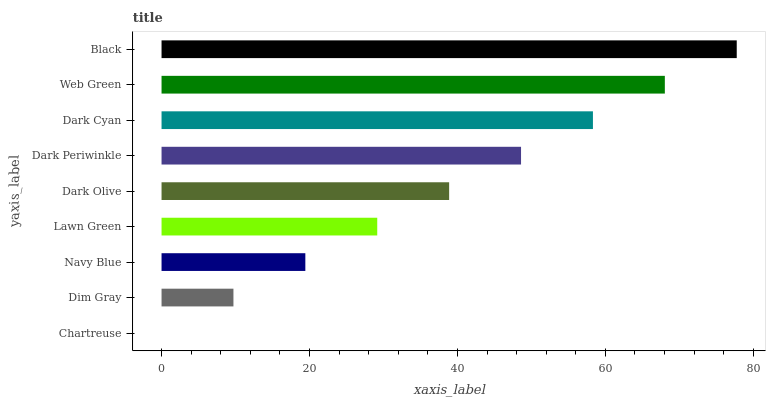Is Chartreuse the minimum?
Answer yes or no. Yes. Is Black the maximum?
Answer yes or no. Yes. Is Dim Gray the minimum?
Answer yes or no. No. Is Dim Gray the maximum?
Answer yes or no. No. Is Dim Gray greater than Chartreuse?
Answer yes or no. Yes. Is Chartreuse less than Dim Gray?
Answer yes or no. Yes. Is Chartreuse greater than Dim Gray?
Answer yes or no. No. Is Dim Gray less than Chartreuse?
Answer yes or no. No. Is Dark Olive the high median?
Answer yes or no. Yes. Is Dark Olive the low median?
Answer yes or no. Yes. Is Dark Cyan the high median?
Answer yes or no. No. Is Navy Blue the low median?
Answer yes or no. No. 